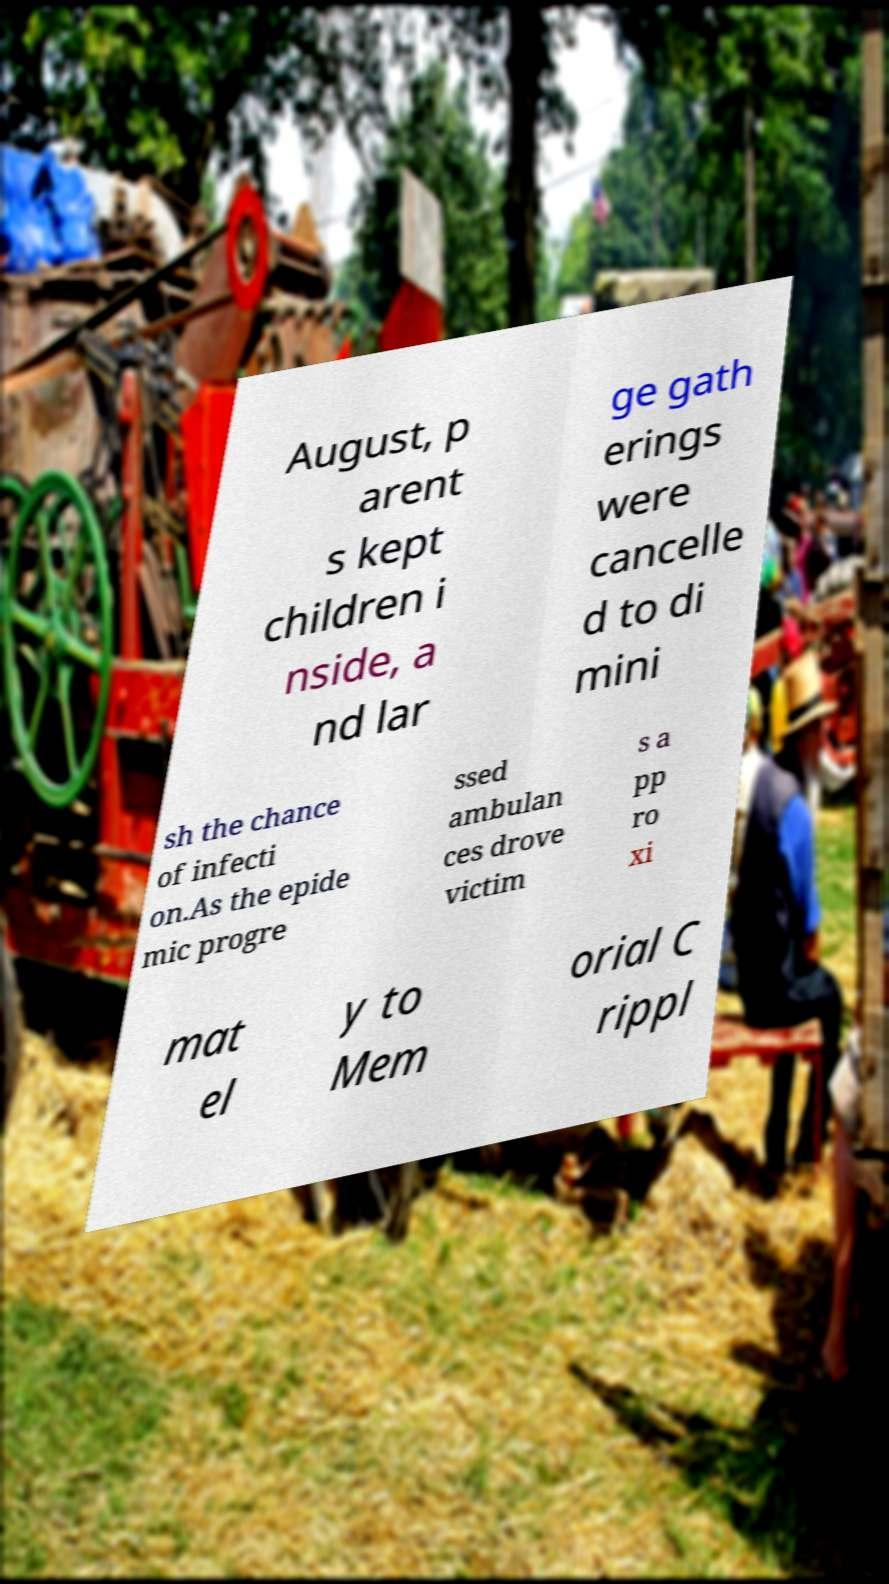There's text embedded in this image that I need extracted. Can you transcribe it verbatim? August, p arent s kept children i nside, a nd lar ge gath erings were cancelle d to di mini sh the chance of infecti on.As the epide mic progre ssed ambulan ces drove victim s a pp ro xi mat el y to Mem orial C rippl 